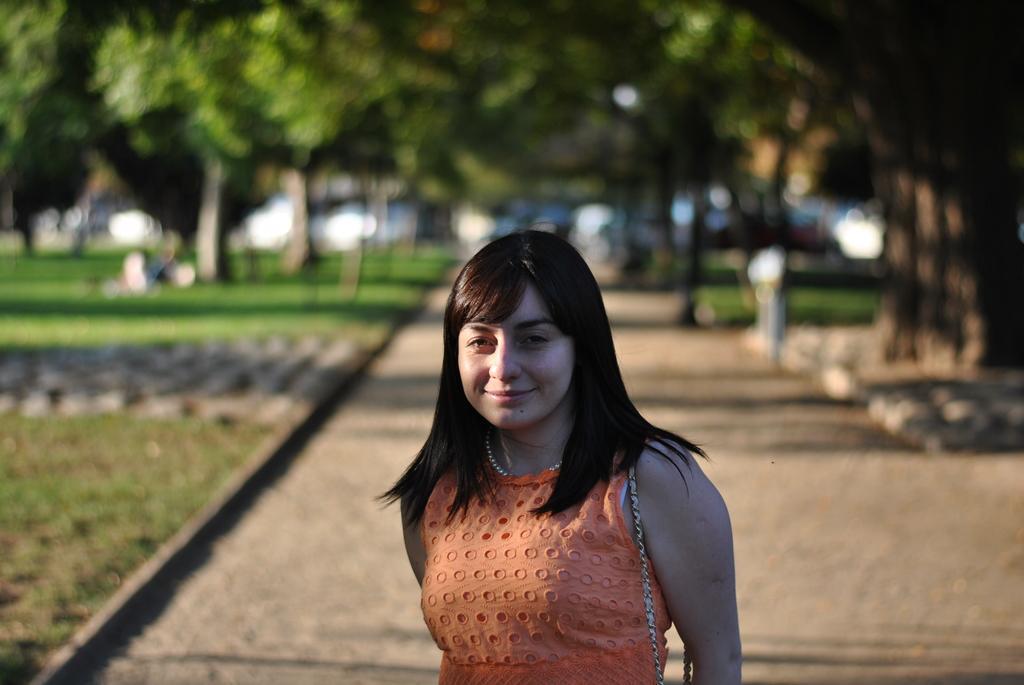In one or two sentences, can you explain what this image depicts? In this picture there is a girl wearing brown color dress, standing in front and smiling. Behind there are many trees. On the left side there is a grass lawn. 